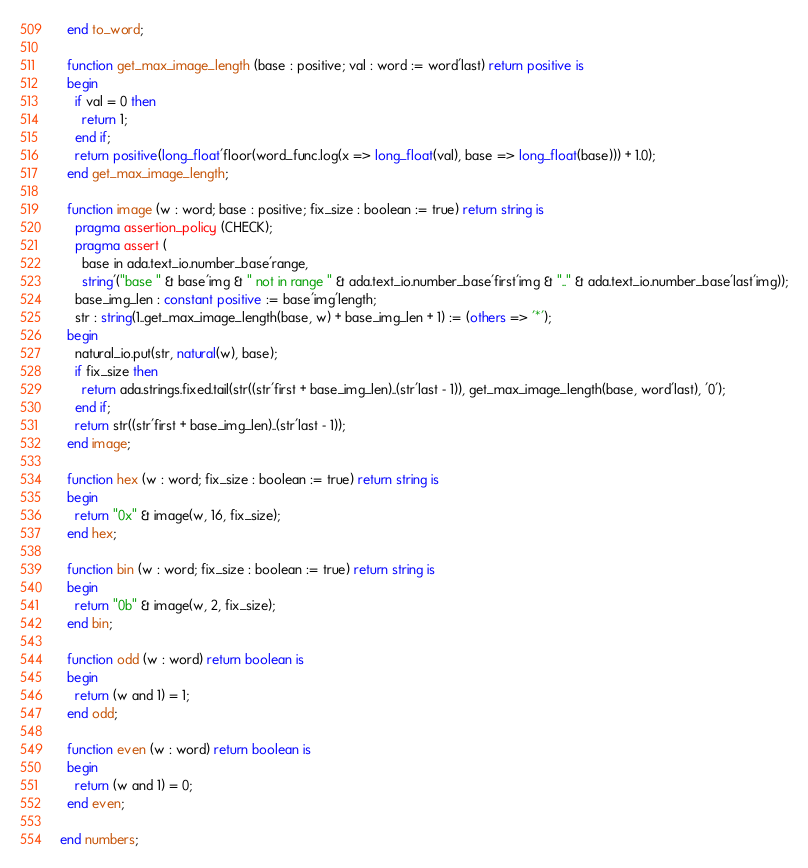Convert code to text. <code><loc_0><loc_0><loc_500><loc_500><_Ada_>  end to_word;

  function get_max_image_length (base : positive; val : word := word'last) return positive is
  begin
    if val = 0 then
      return 1;
    end if;
    return positive(long_float'floor(word_func.log(x => long_float(val), base => long_float(base))) + 1.0);
  end get_max_image_length;

  function image (w : word; base : positive; fix_size : boolean := true) return string is
    pragma assertion_policy (CHECK);
    pragma assert (
      base in ada.text_io.number_base'range,
      string'("base " & base'img & " not in range " & ada.text_io.number_base'first'img & ".." & ada.text_io.number_base'last'img));
    base_img_len : constant positive := base'img'length;
    str : string(1..get_max_image_length(base, w) + base_img_len + 1) := (others => '*');
  begin
    natural_io.put(str, natural(w), base);
    if fix_size then
      return ada.strings.fixed.tail(str((str'first + base_img_len)..(str'last - 1)), get_max_image_length(base, word'last), '0');
    end if;
    return str((str'first + base_img_len)..(str'last - 1));
  end image;

  function hex (w : word; fix_size : boolean := true) return string is
  begin
    return "0x" & image(w, 16, fix_size);
  end hex;

  function bin (w : word; fix_size : boolean := true) return string is
  begin
    return "0b" & image(w, 2, fix_size);
  end bin;

  function odd (w : word) return boolean is
  begin
    return (w and 1) = 1;
  end odd;

  function even (w : word) return boolean is
  begin
    return (w and 1) = 0;
  end even;

end numbers;</code> 